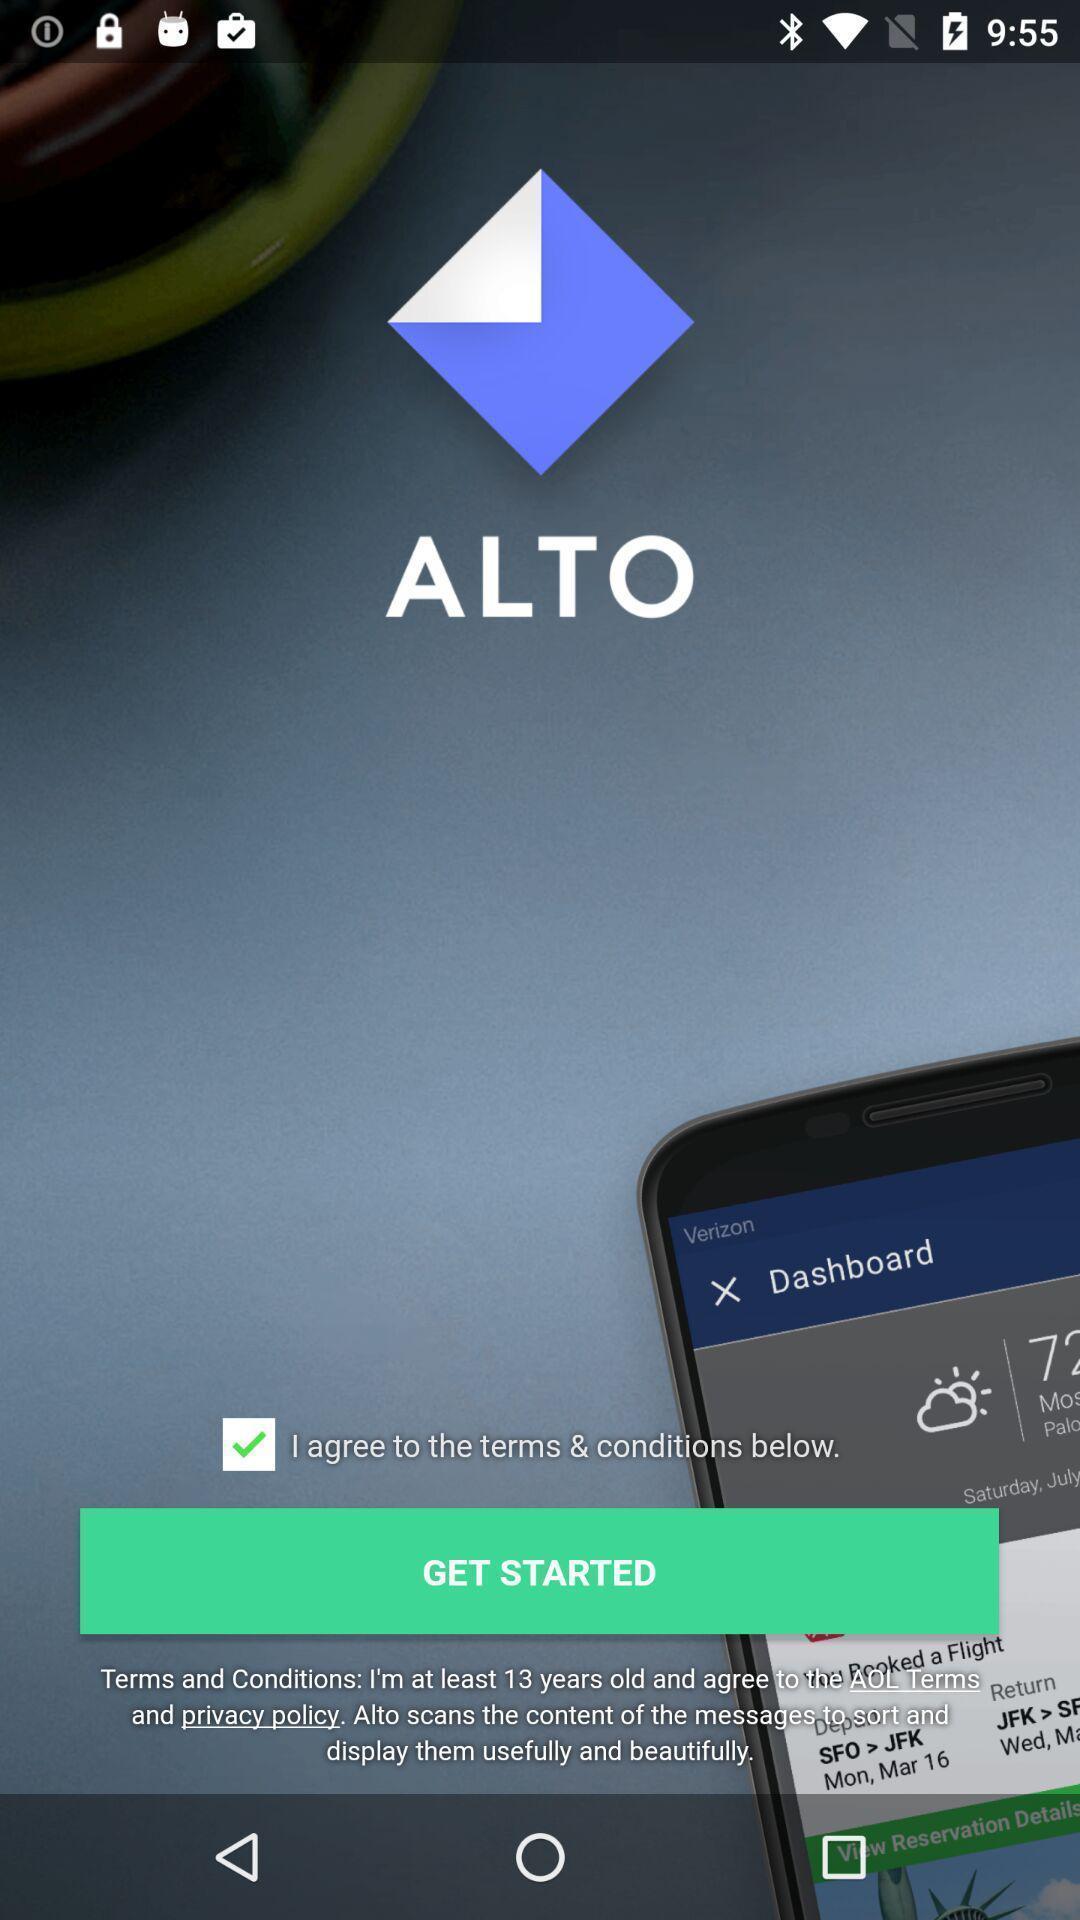Provide a description of this screenshot. Welcome page. 